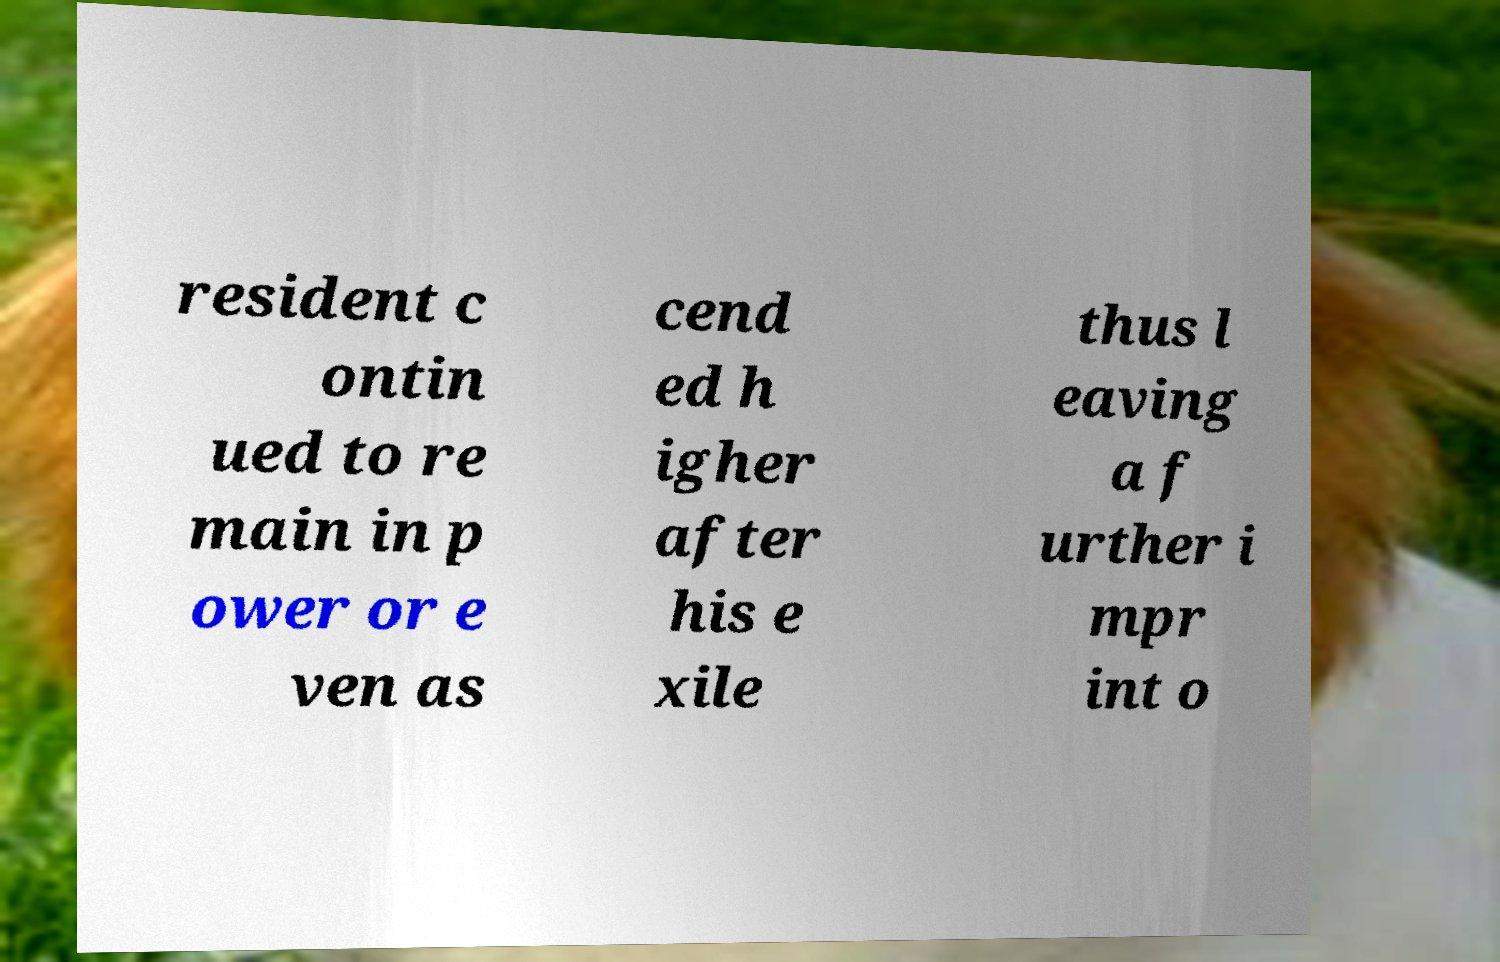For documentation purposes, I need the text within this image transcribed. Could you provide that? resident c ontin ued to re main in p ower or e ven as cend ed h igher after his e xile thus l eaving a f urther i mpr int o 